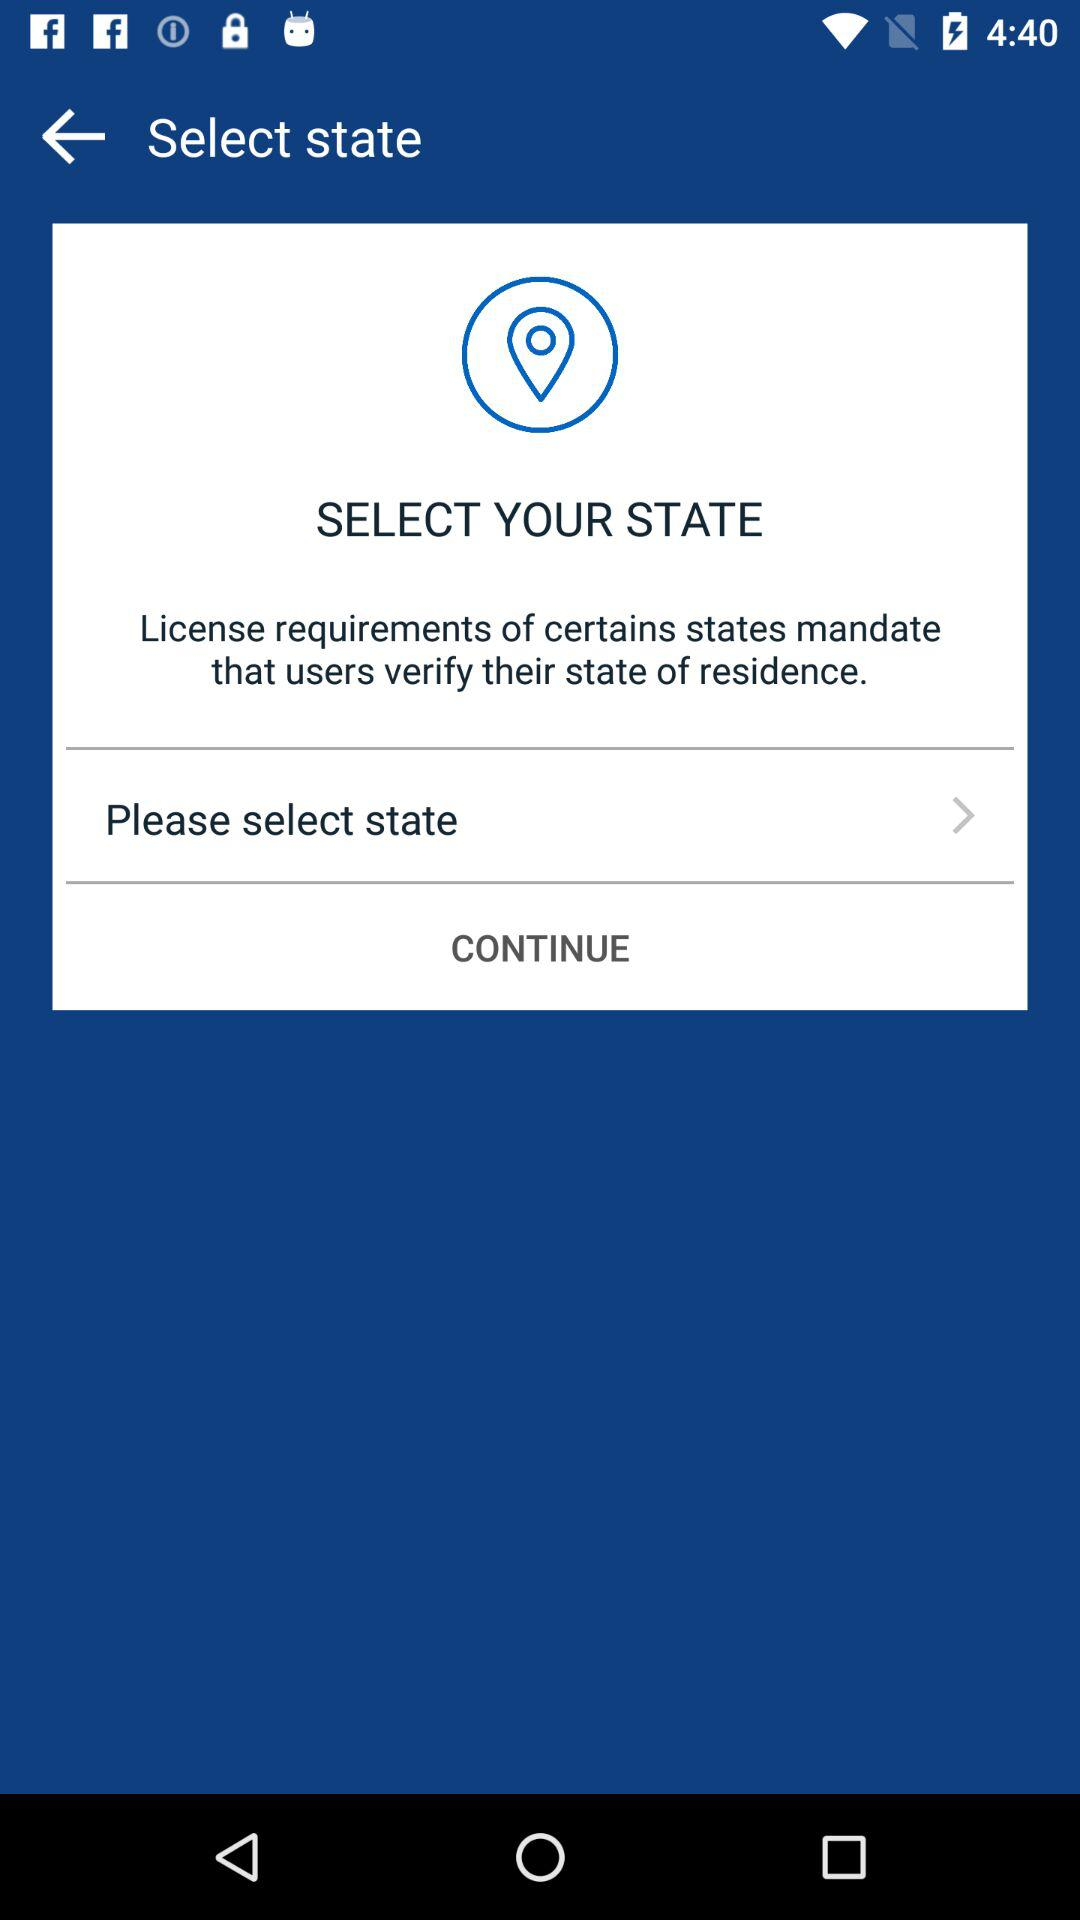What is the "Bitcoin" price? The "Bitcoin" price is $1,063.97. 